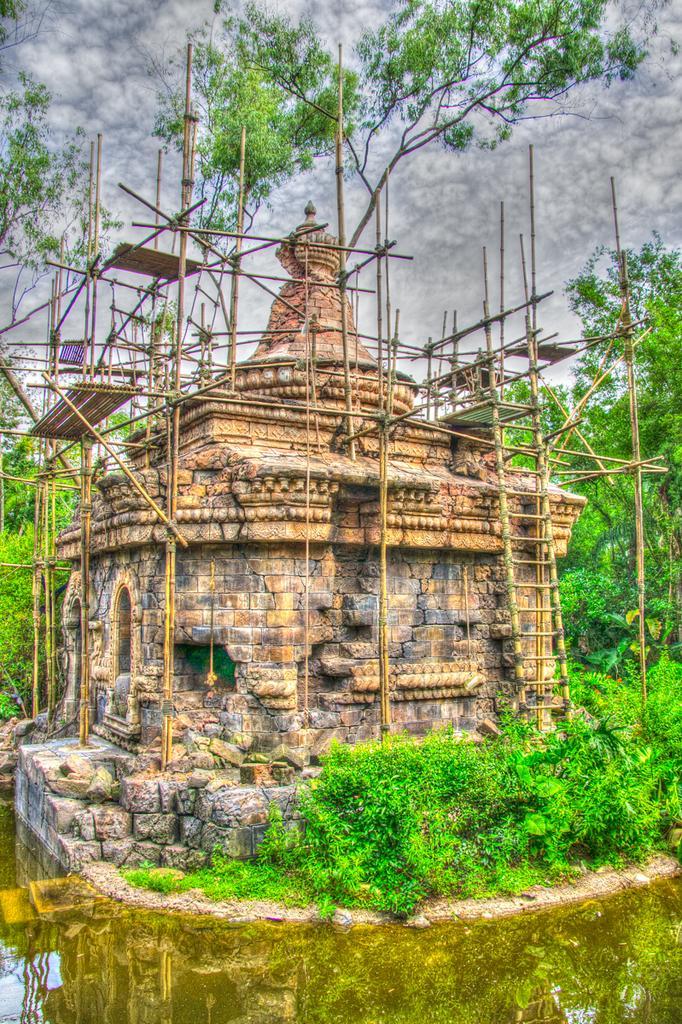Can you describe this image briefly? In the foreground of the picture there are plants, stones and water. In the center of the picture we can see a temple and wooden poles. In the background there are trees and sky. The image is an edited image. 